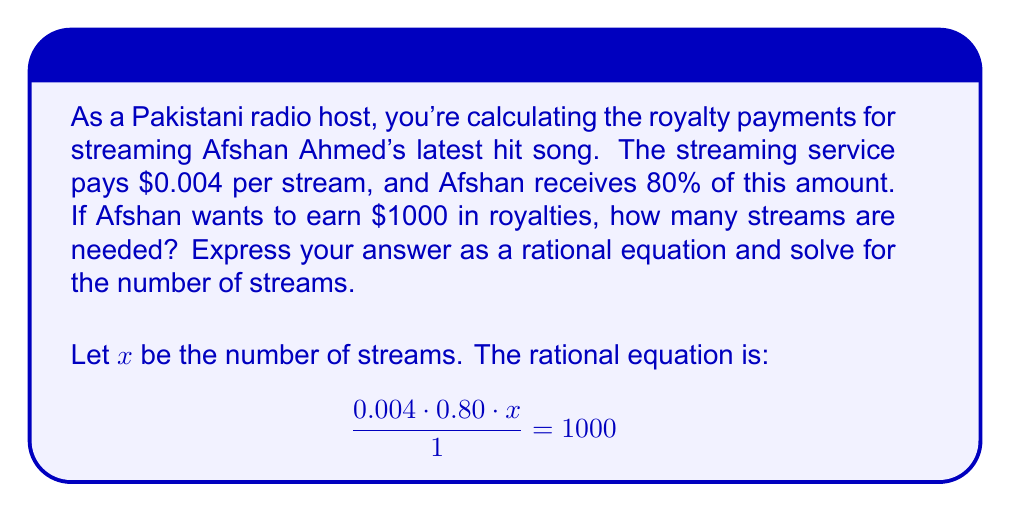Help me with this question. Let's solve this rational equation step by step:

1) First, let's simplify the left side of the equation:
   $$ 0.004 \cdot 0.80 \cdot x = 1000 $$

2) Multiply both sides by 1 (which doesn't change the equation):
   $$ 0.0032x = 1000 $$

3) Now, divide both sides by 0.0032 to isolate x:
   $$ x = \frac{1000}{0.0032} $$

4) To calculate this, we can use the division property of fractions:
   $$ x = 1000 \cdot \frac{1000}{3.2} = \frac{1,000,000}{3.2} $$

5) Simplify:
   $$ x = 312,500 $$

Therefore, 312,500 streams are needed for Afshan Ahmed to earn $1000 in royalties.
Answer: 312,500 streams 